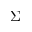<formula> <loc_0><loc_0><loc_500><loc_500>\Sigma</formula> 